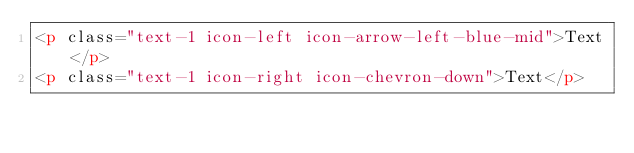Convert code to text. <code><loc_0><loc_0><loc_500><loc_500><_HTML_><p class="text-1 icon-left icon-arrow-left-blue-mid">Text</p>
<p class="text-1 icon-right icon-chevron-down">Text</p>
</code> 